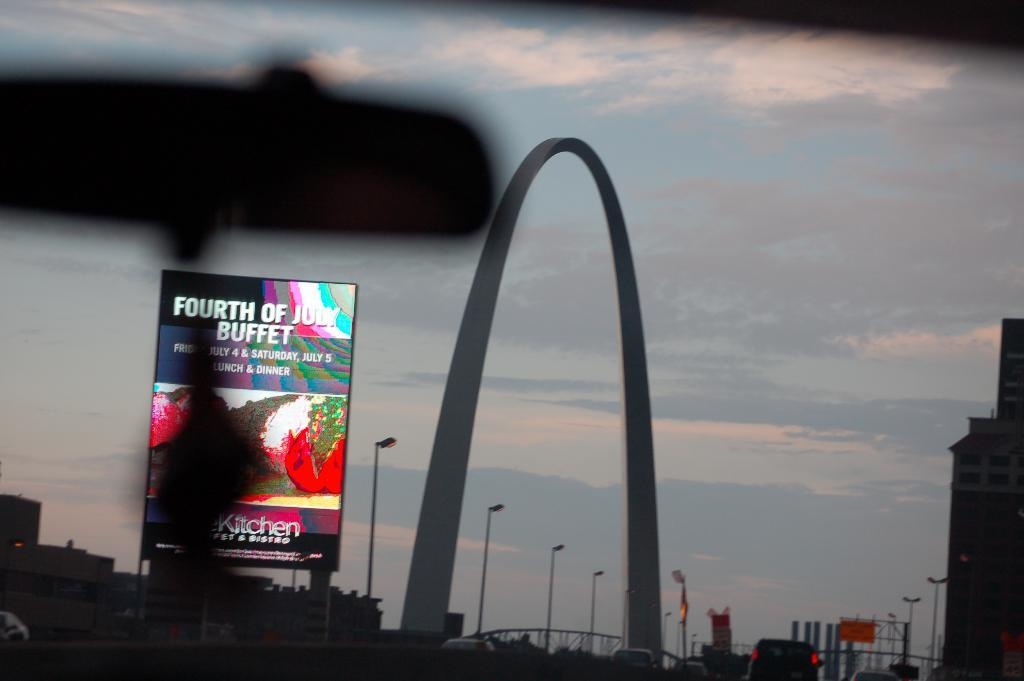Provide a one-sentence caption for the provided image. A large arch with a sign for a buffet on the left. 